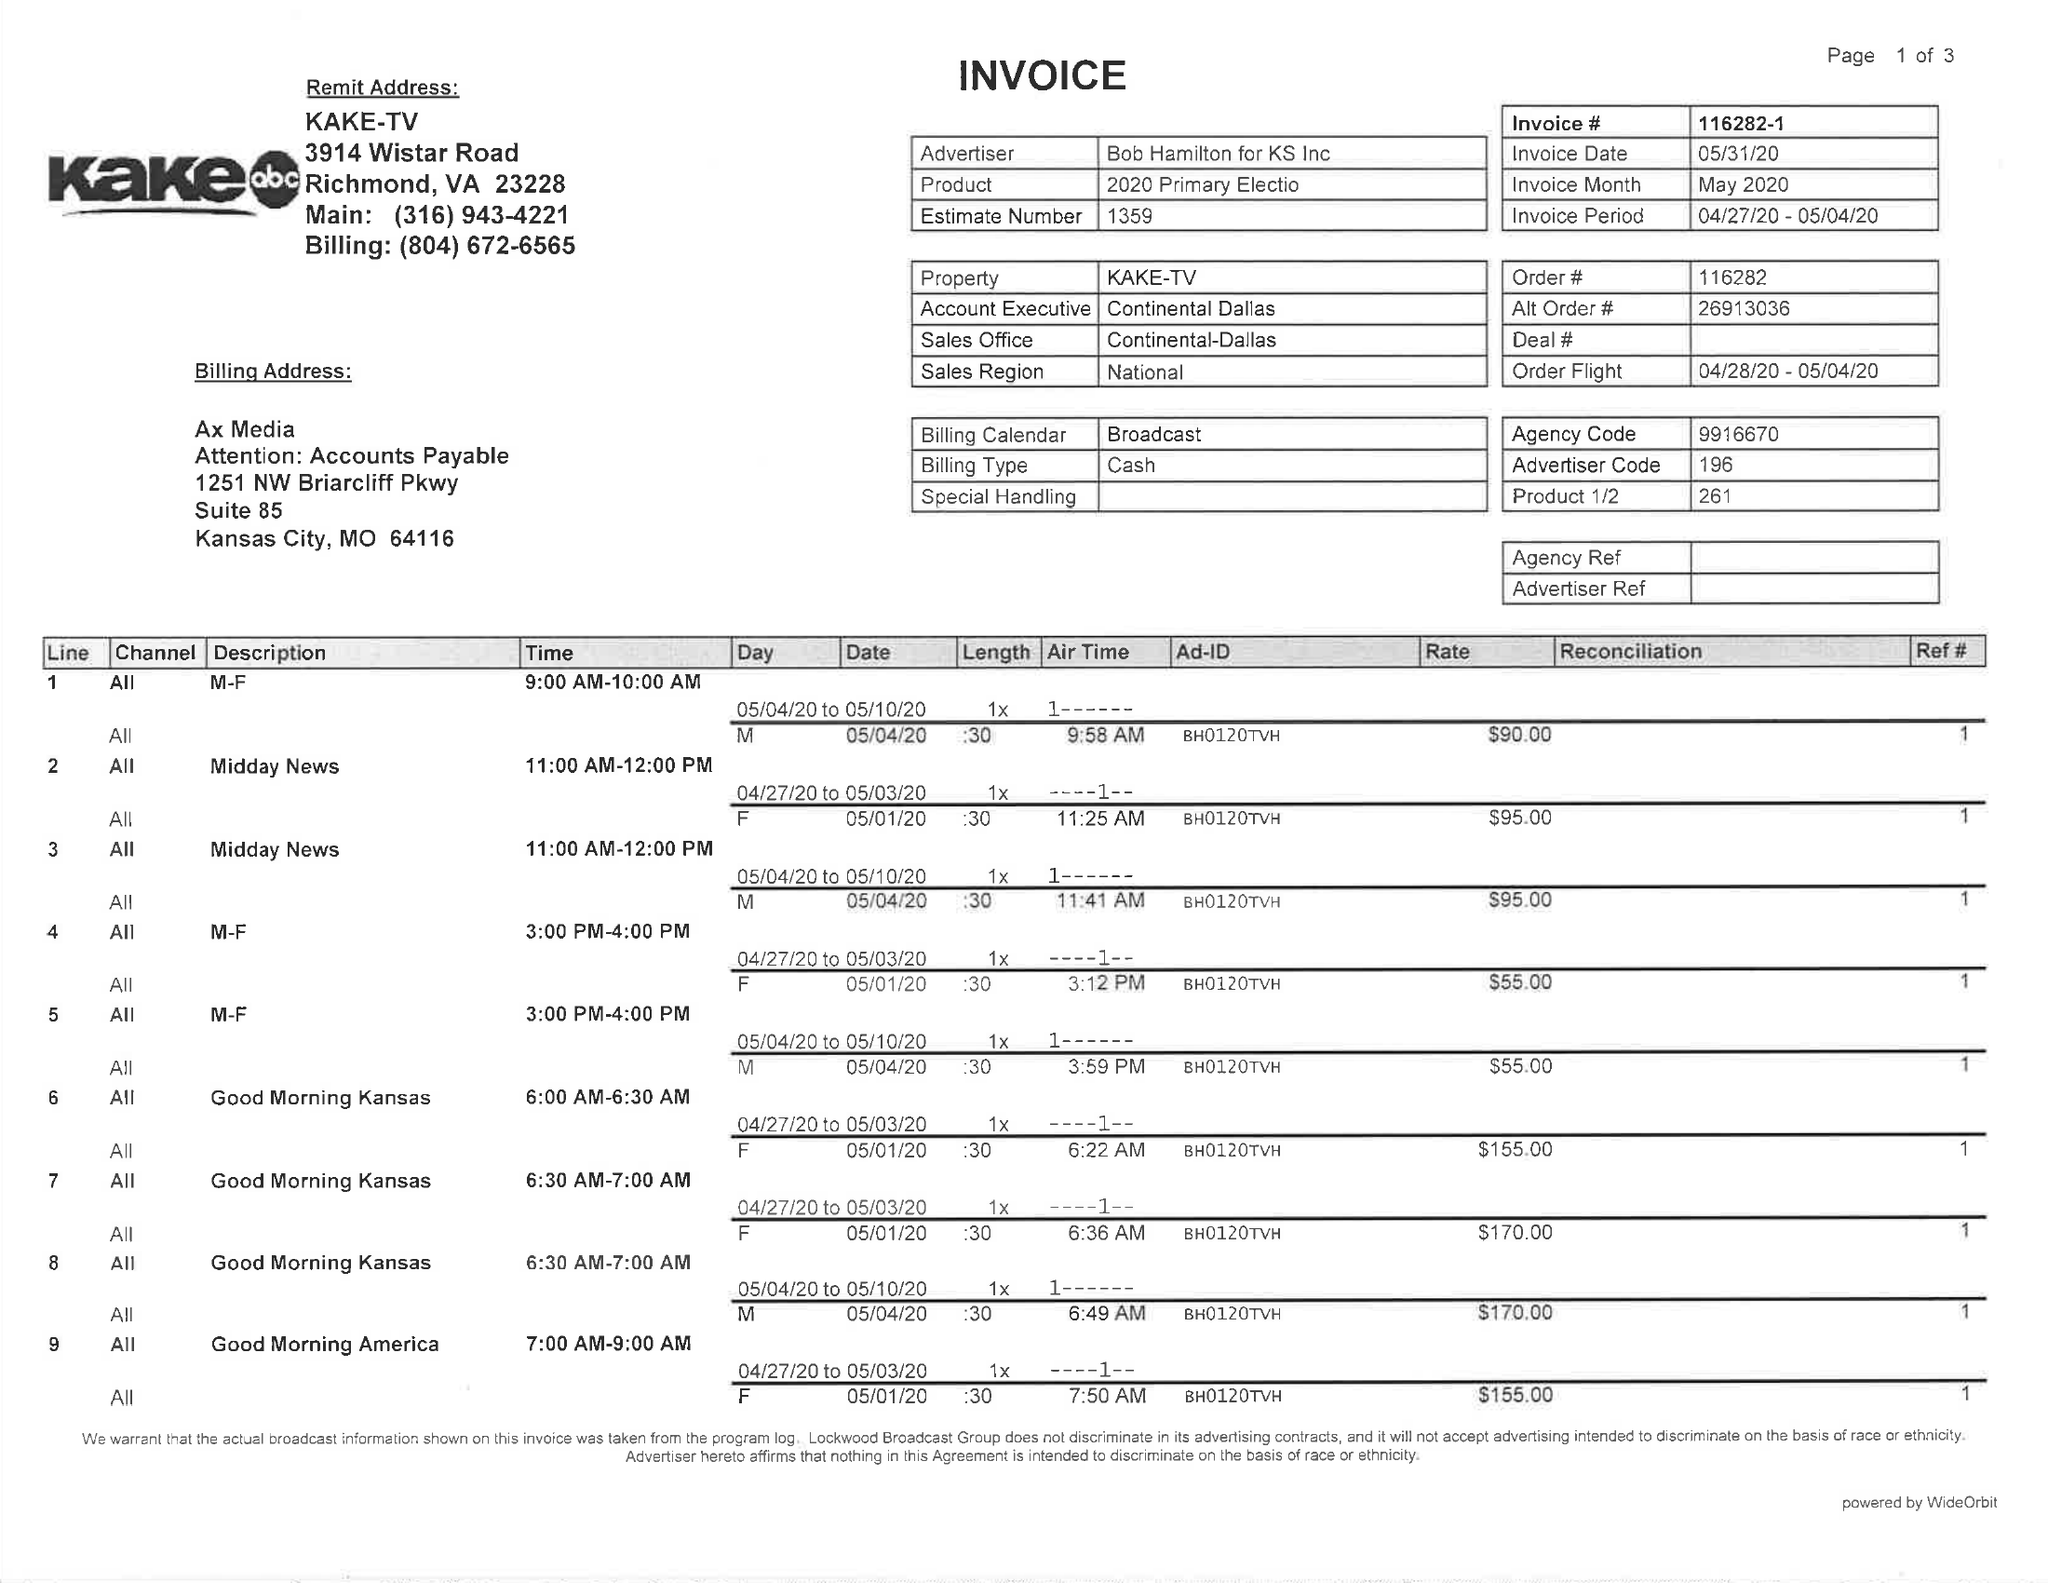What is the value for the contract_num?
Answer the question using a single word or phrase. 116282 